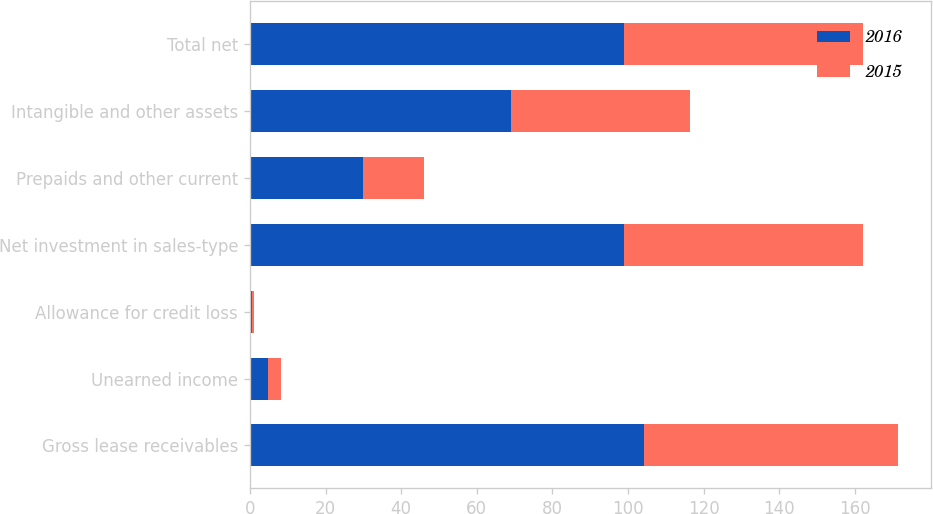Convert chart to OTSL. <chart><loc_0><loc_0><loc_500><loc_500><stacked_bar_chart><ecel><fcel>Gross lease receivables<fcel>Unearned income<fcel>Allowance for credit loss<fcel>Net investment in sales-type<fcel>Prepaids and other current<fcel>Intangible and other assets<fcel>Total net<nl><fcel>2016<fcel>104.3<fcel>4.8<fcel>0.6<fcel>98.9<fcel>29.8<fcel>69.1<fcel>98.9<nl><fcel>2015<fcel>67.1<fcel>3.4<fcel>0.4<fcel>63.3<fcel>16.1<fcel>47.2<fcel>63.3<nl></chart> 